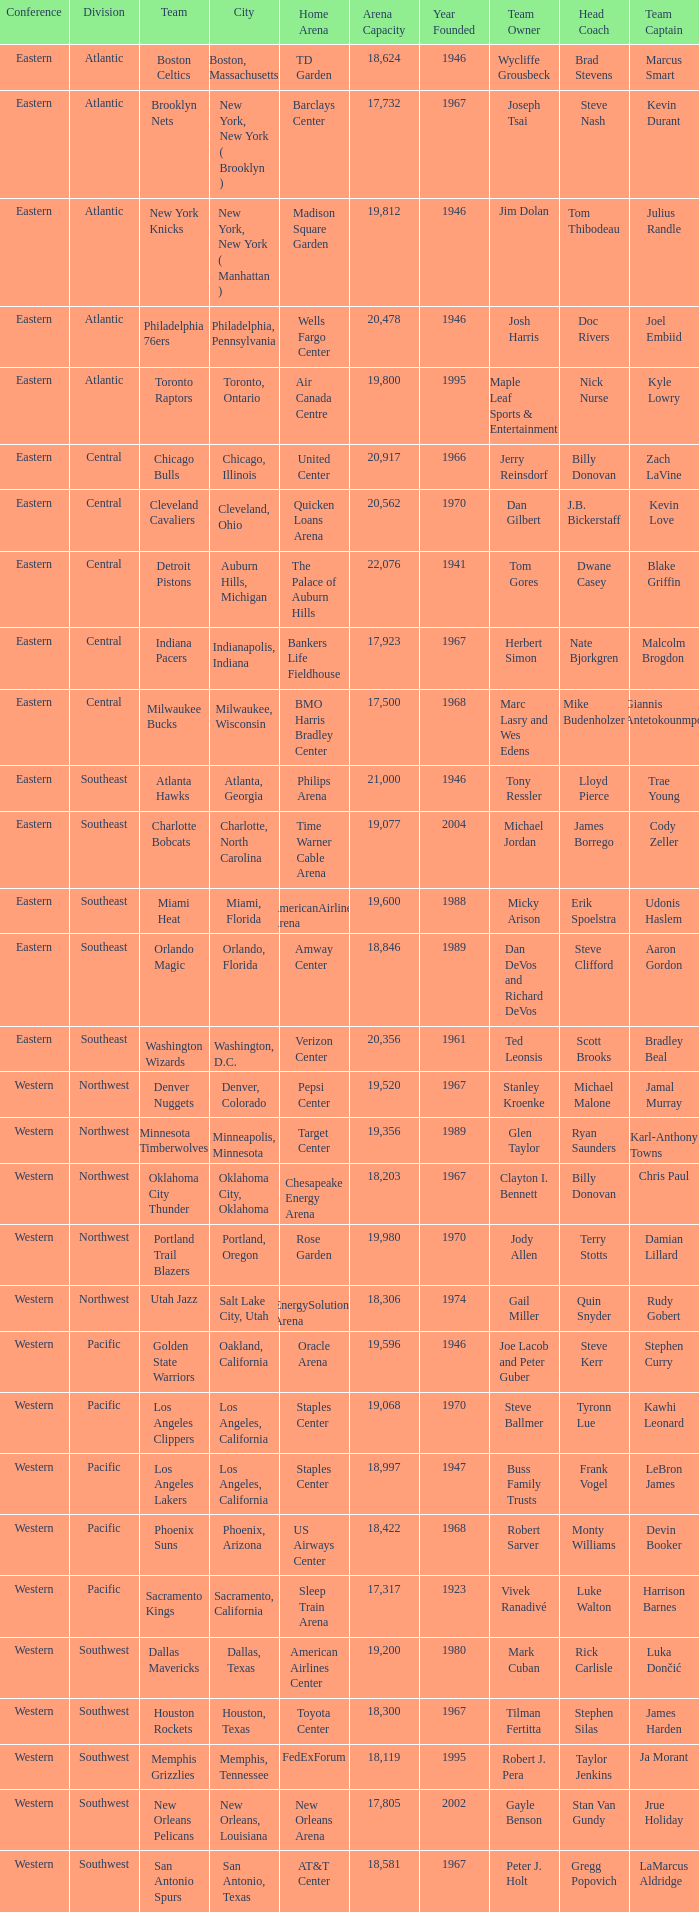Which city includes Barclays Center? New York, New York ( Brooklyn ). 